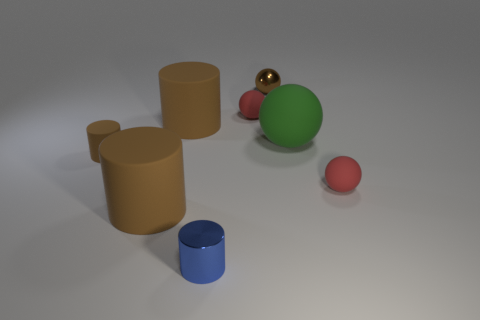What number of matte objects have the same shape as the blue metal thing?
Your answer should be very brief. 3. Are there more tiny cylinders that are to the left of the blue cylinder than tiny red matte cubes?
Make the answer very short. Yes. What is the shape of the metallic thing behind the large cylinder that is in front of the big thing that is on the right side of the metal sphere?
Ensure brevity in your answer.  Sphere. There is a small rubber object that is left of the tiny blue metallic object; is it the same shape as the tiny metallic thing that is to the left of the small brown metal sphere?
Offer a terse response. Yes. What number of balls are either brown rubber objects or small red things?
Offer a terse response. 2. Is the tiny brown ball made of the same material as the big sphere?
Your answer should be compact. No. How many other objects are the same color as the metal sphere?
Provide a succinct answer. 3. There is a big rubber thing to the right of the blue thing; what is its shape?
Give a very brief answer. Sphere. What number of objects are metallic blocks or small blue metallic cylinders?
Offer a very short reply. 1. Is the size of the blue thing the same as the metallic object to the right of the small blue cylinder?
Your answer should be compact. Yes. 